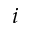<formula> <loc_0><loc_0><loc_500><loc_500>i</formula> 